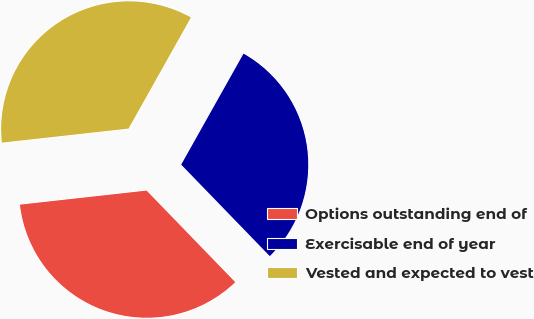<chart> <loc_0><loc_0><loc_500><loc_500><pie_chart><fcel>Options outstanding end of<fcel>Exercisable end of year<fcel>Vested and expected to vest<nl><fcel>35.48%<fcel>29.61%<fcel>34.9%<nl></chart> 